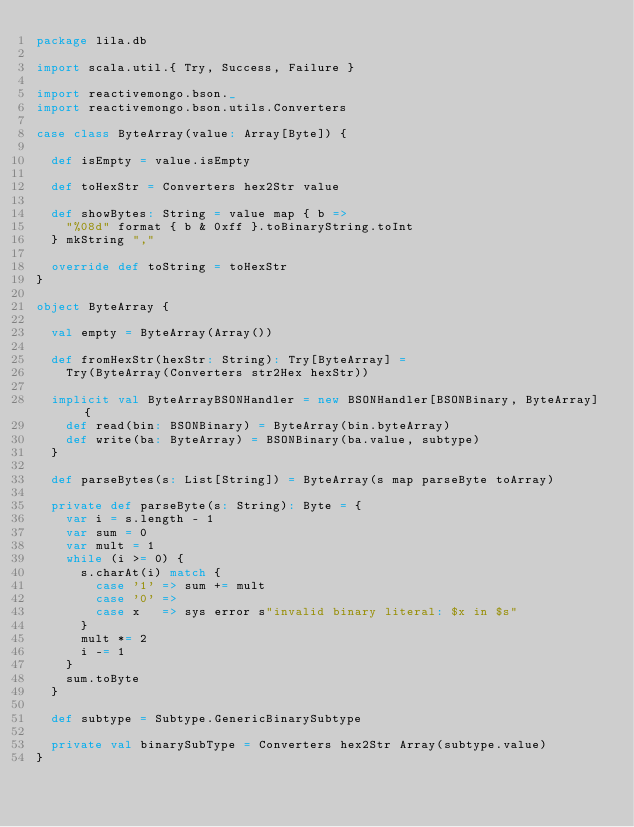<code> <loc_0><loc_0><loc_500><loc_500><_Scala_>package lila.db

import scala.util.{ Try, Success, Failure }

import reactivemongo.bson._
import reactivemongo.bson.utils.Converters

case class ByteArray(value: Array[Byte]) {

  def isEmpty = value.isEmpty

  def toHexStr = Converters hex2Str value

  def showBytes: String = value map { b =>
    "%08d" format { b & 0xff }.toBinaryString.toInt
  } mkString ","

  override def toString = toHexStr
}

object ByteArray {

  val empty = ByteArray(Array())

  def fromHexStr(hexStr: String): Try[ByteArray] =
    Try(ByteArray(Converters str2Hex hexStr))

  implicit val ByteArrayBSONHandler = new BSONHandler[BSONBinary, ByteArray] {
    def read(bin: BSONBinary) = ByteArray(bin.byteArray)
    def write(ba: ByteArray) = BSONBinary(ba.value, subtype)
  }

  def parseBytes(s: List[String]) = ByteArray(s map parseByte toArray)

  private def parseByte(s: String): Byte = {
    var i = s.length - 1
    var sum = 0
    var mult = 1
    while (i >= 0) {
      s.charAt(i) match {
        case '1' => sum += mult
        case '0' =>
        case x   => sys error s"invalid binary literal: $x in $s"
      }
      mult *= 2
      i -= 1
    }
    sum.toByte
  }

  def subtype = Subtype.GenericBinarySubtype

  private val binarySubType = Converters hex2Str Array(subtype.value)
}
</code> 